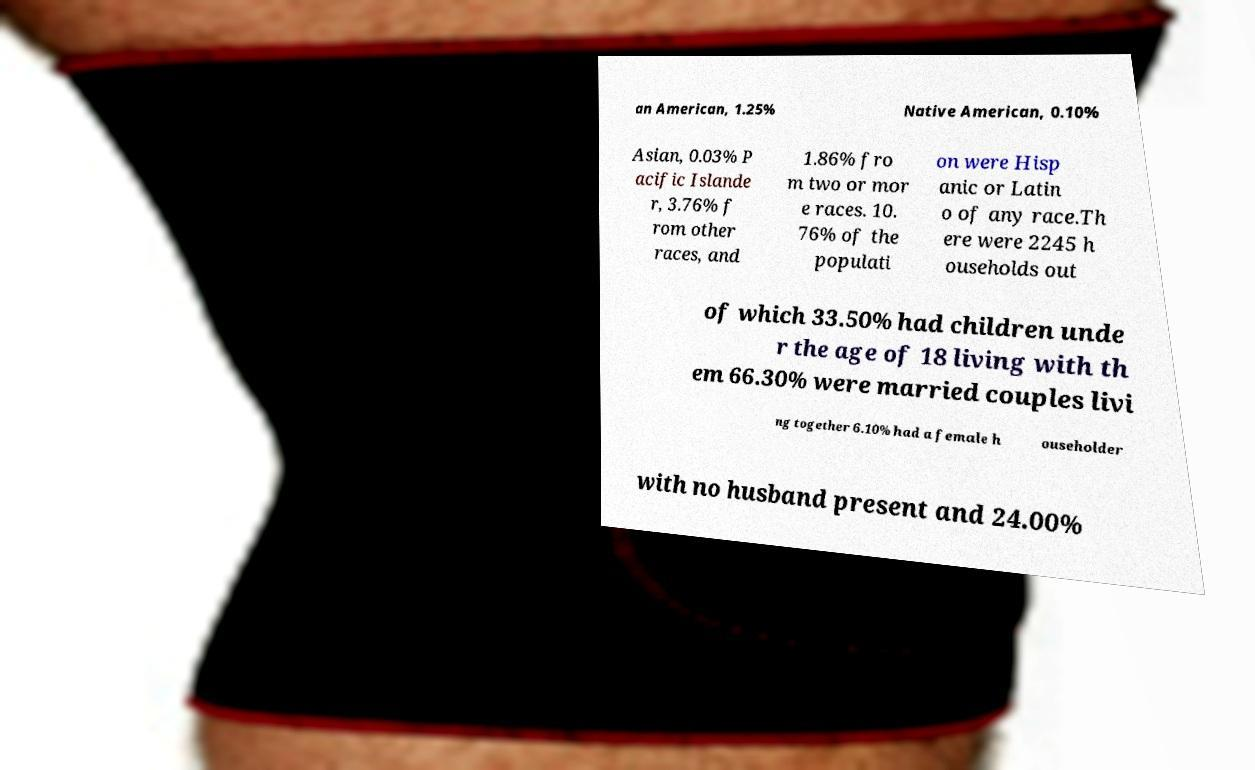Could you assist in decoding the text presented in this image and type it out clearly? an American, 1.25% Native American, 0.10% Asian, 0.03% P acific Islande r, 3.76% f rom other races, and 1.86% fro m two or mor e races. 10. 76% of the populati on were Hisp anic or Latin o of any race.Th ere were 2245 h ouseholds out of which 33.50% had children unde r the age of 18 living with th em 66.30% were married couples livi ng together 6.10% had a female h ouseholder with no husband present and 24.00% 